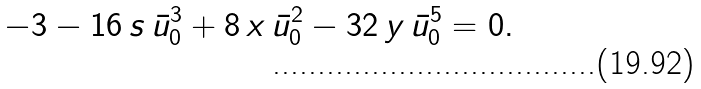<formula> <loc_0><loc_0><loc_500><loc_500>- 3 - 1 6 \, s \, \bar { u } _ { 0 } ^ { 3 } + 8 \, x \, \bar { u } _ { 0 } ^ { 2 } - 3 2 \, y \, \bar { u } _ { 0 } ^ { 5 } = 0 .</formula> 